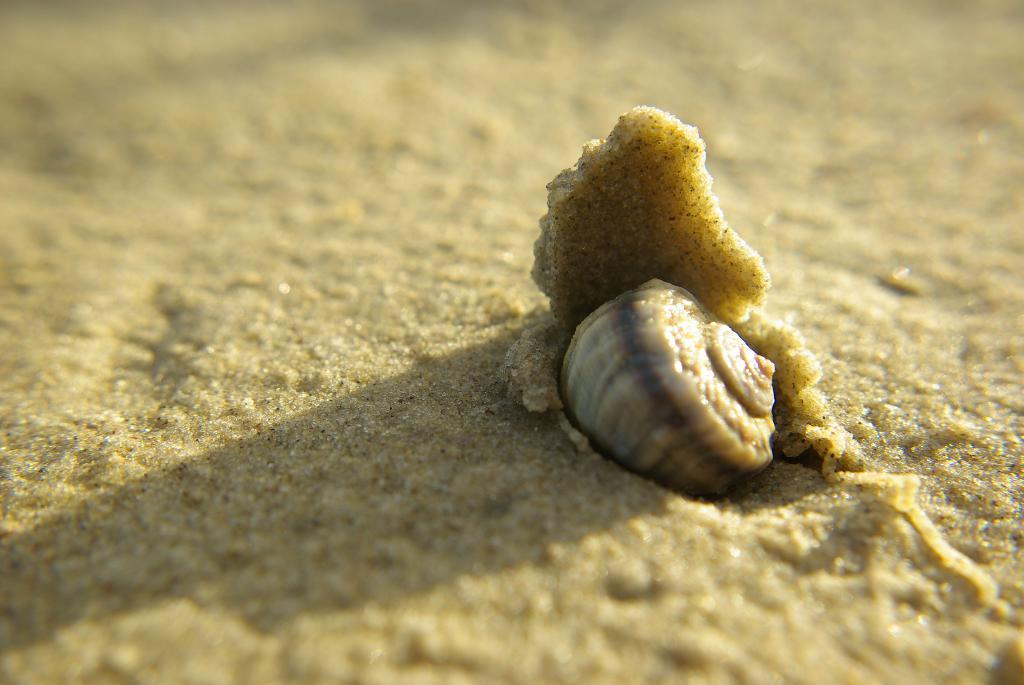What type of surface is visible in the image? There is sand in the image. What object can be seen on the sand? There is a shell on the sand. Can you describe any other features in the image? There is a shadow visible on the left side of the image. Where is the kitty hiding with the spoon in the image? There is no kitty or spoon present in the image. Is the spy visible in the image? There is no indication of a spy or any espionage activity in the image. 